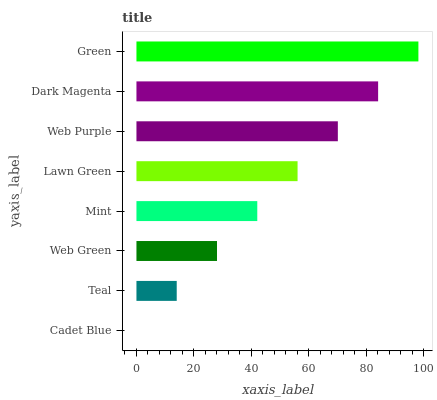Is Cadet Blue the minimum?
Answer yes or no. Yes. Is Green the maximum?
Answer yes or no. Yes. Is Teal the minimum?
Answer yes or no. No. Is Teal the maximum?
Answer yes or no. No. Is Teal greater than Cadet Blue?
Answer yes or no. Yes. Is Cadet Blue less than Teal?
Answer yes or no. Yes. Is Cadet Blue greater than Teal?
Answer yes or no. No. Is Teal less than Cadet Blue?
Answer yes or no. No. Is Lawn Green the high median?
Answer yes or no. Yes. Is Mint the low median?
Answer yes or no. Yes. Is Teal the high median?
Answer yes or no. No. Is Teal the low median?
Answer yes or no. No. 